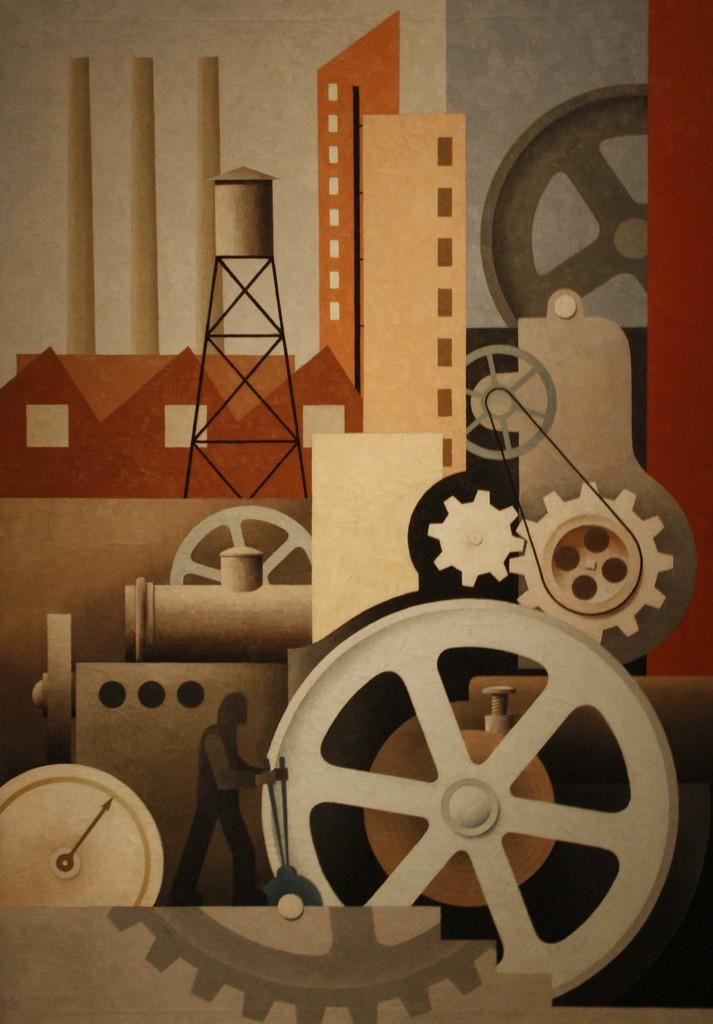What type of image is being described? The image is animated. What objects can be seen in the image? There are mechanical instruments in the image. What type of coat is being worn by the character in the image? There is no character or coat present in the image; it only features mechanical instruments. What type of jewel can be seen on the character's neck in the image? There is no character or jewel present in the image; it only features mechanical instruments. 